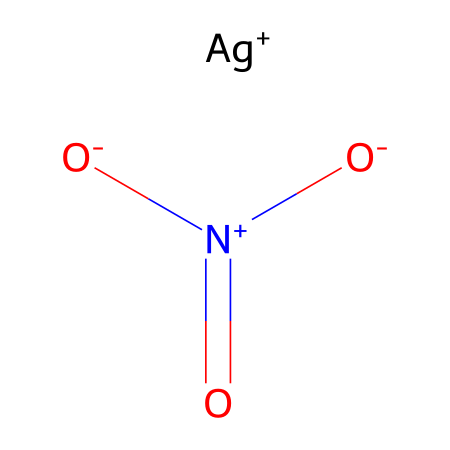What is the chemical name of this structure? The SMILES representation indicates the presence of silver (Ag) and nitrate (NO3), which when combined forms silver nitrate.
Answer: silver nitrate How many oxygen atoms are present in this molecule? Analyzing the SMILES shows three oxygen atoms present as indicated by the notation [O-] and another [O] in the nitrate group.
Answer: three What is the oxidation state of silver in this compound? The notation [Ag+] indicates that silver has a +1 oxidation state. This is typical for silver when it forms ionic compounds.
Answer: +1 How many total atoms are present in this structure? Counting the atoms from the SMILES yields one silver atom, one nitrogen atom, and three oxygen atoms, totaling five atoms.
Answer: five What type of bond connects the nitrogen and oxygen in silver nitrate? The nitrogen atom has a double bond with one of the oxygen atoms as indicated by the "=" sign, which denotes a double bond in chemical structures.
Answer: double bond Is silver nitrate soluble in water? Silver nitrate is known to be soluble in water, which is a common property of many nitrate salts.
Answer: soluble Which part of this compound primarily contributes to its use in mirror-making? The metallic silver ion (Ag+) is primarily responsible for the reflective properties that are utilized in mirror-making.
Answer: Ag+ 